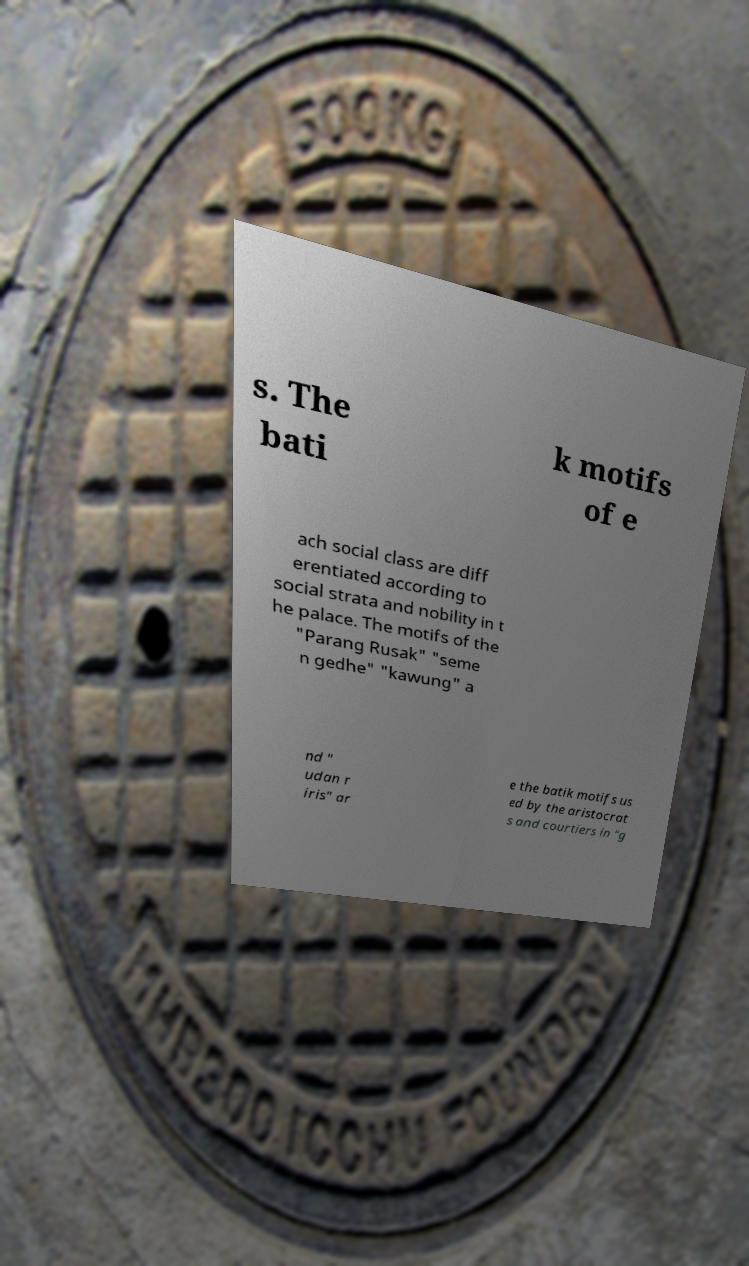What messages or text are displayed in this image? I need them in a readable, typed format. s. The bati k motifs of e ach social class are diff erentiated according to social strata and nobility in t he palace. The motifs of the "Parang Rusak" "seme n gedhe" "kawung" a nd " udan r iris" ar e the batik motifs us ed by the aristocrat s and courtiers in "g 